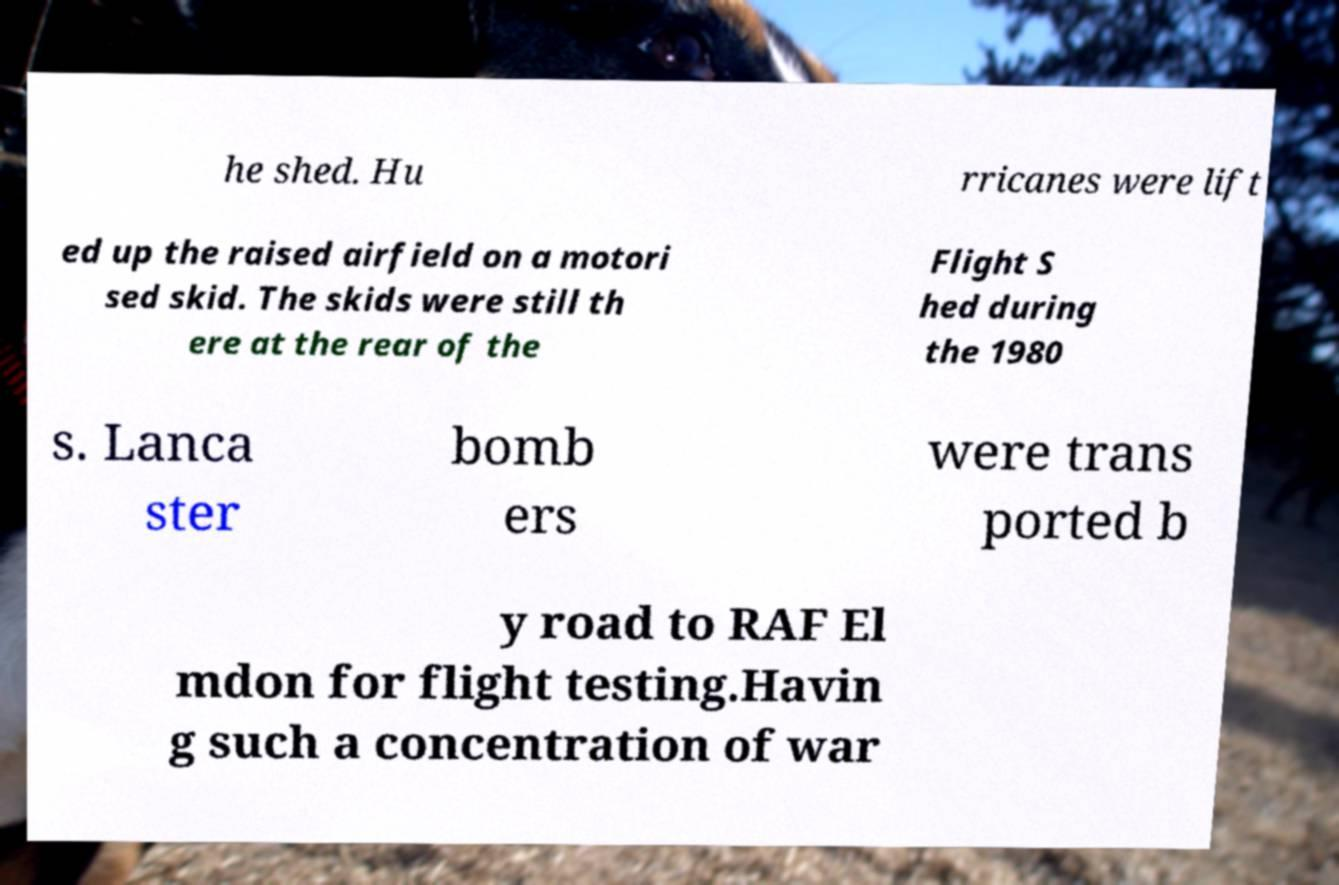I need the written content from this picture converted into text. Can you do that? he shed. Hu rricanes were lift ed up the raised airfield on a motori sed skid. The skids were still th ere at the rear of the Flight S hed during the 1980 s. Lanca ster bomb ers were trans ported b y road to RAF El mdon for flight testing.Havin g such a concentration of war 